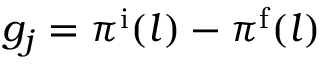Convert formula to latex. <formula><loc_0><loc_0><loc_500><loc_500>g _ { j } = \pi ^ { \mathrm i } ( l ) - \pi ^ { \mathrm f } ( l )</formula> 